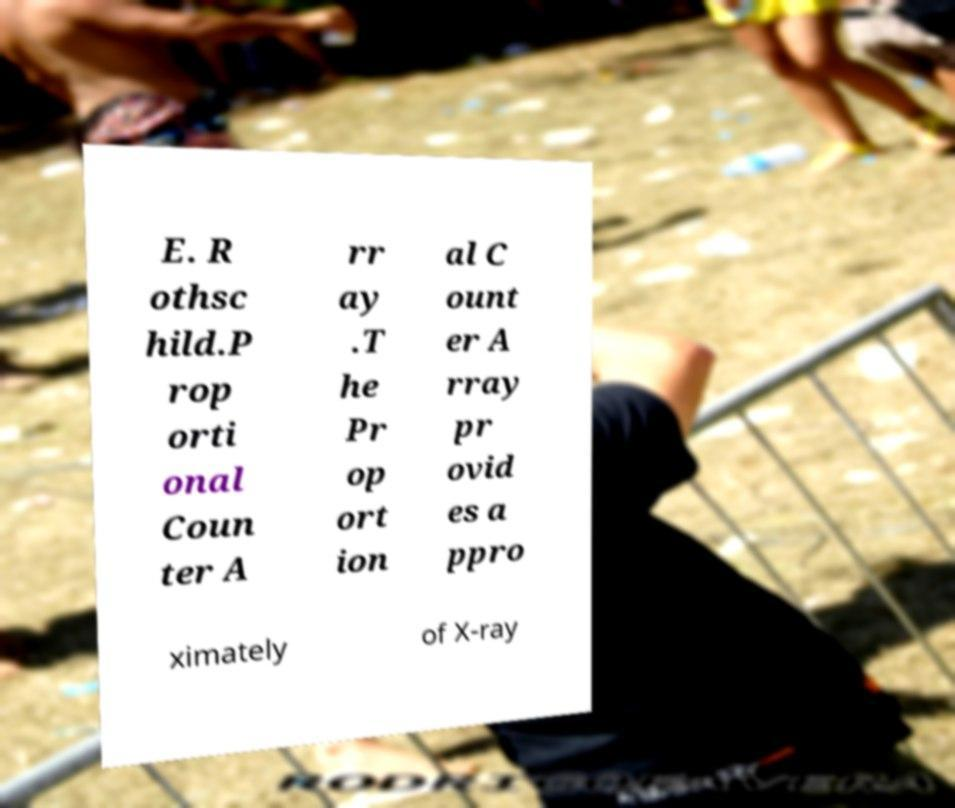I need the written content from this picture converted into text. Can you do that? E. R othsc hild.P rop orti onal Coun ter A rr ay .T he Pr op ort ion al C ount er A rray pr ovid es a ppro ximately of X-ray 